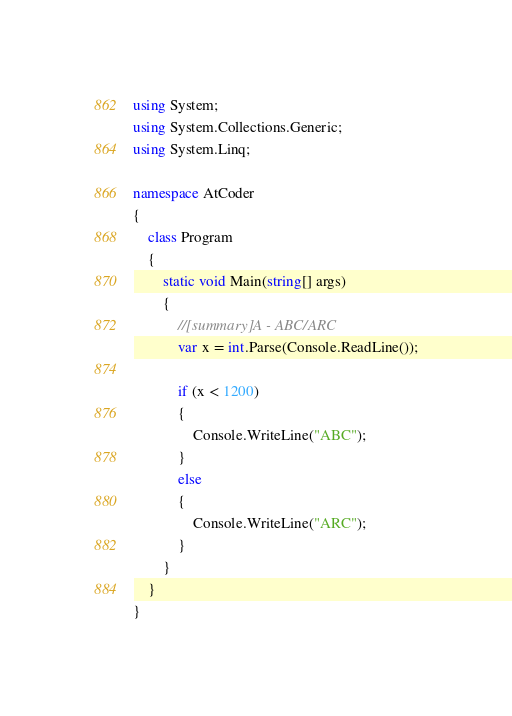Convert code to text. <code><loc_0><loc_0><loc_500><loc_500><_C#_>using System;
using System.Collections.Generic;
using System.Linq;

namespace AtCoder
{
    class Program
    {
        static void Main(string[] args)
        {
            //[summary]A - ABC/ARC
            var x = int.Parse(Console.ReadLine());

            if (x < 1200)
            {
                Console.WriteLine("ABC");
            }
            else
            {
                Console.WriteLine("ARC");
            }
        }
    }
}</code> 